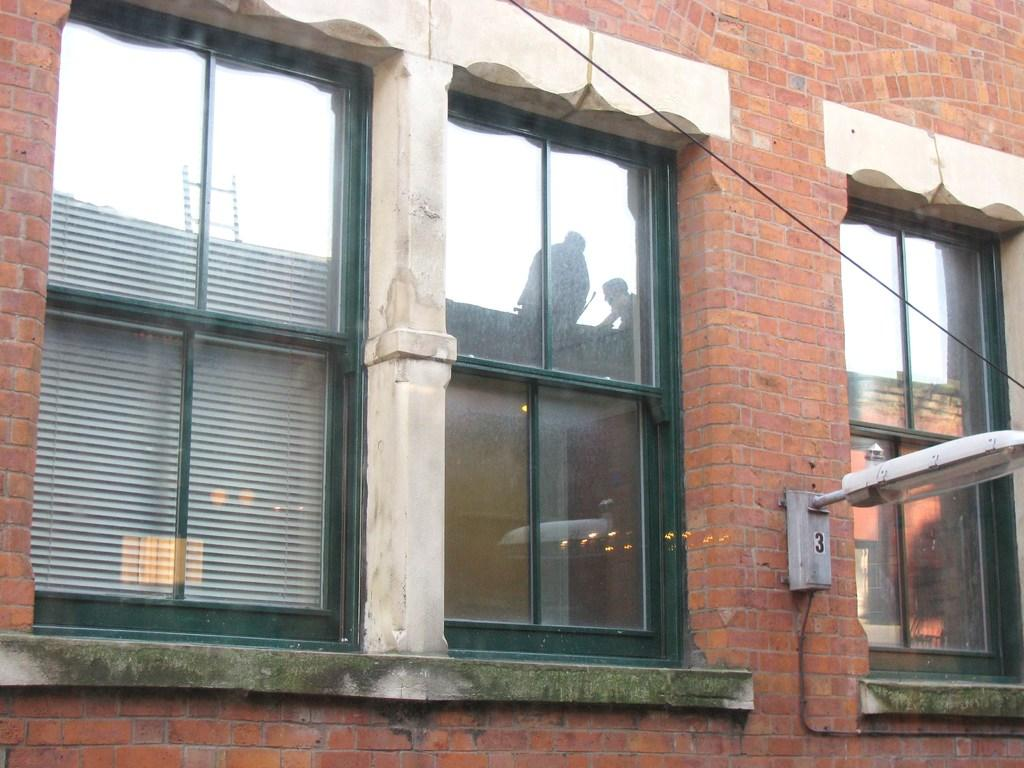What type of material is used for the windows in the image? The windows in the image are made of glass. What kind of wall is visible in the image? There is a brick wall in the image. Where is the light located in the image? The light is on the wall at the right side of the image. What word is being used to describe the light in the image? There is no specific word being used to describe the light in the image; it is simply referred to as a light on the wall. How does the brick wall blow in the image? The brick wall does not blow in the image; it is stationary. 